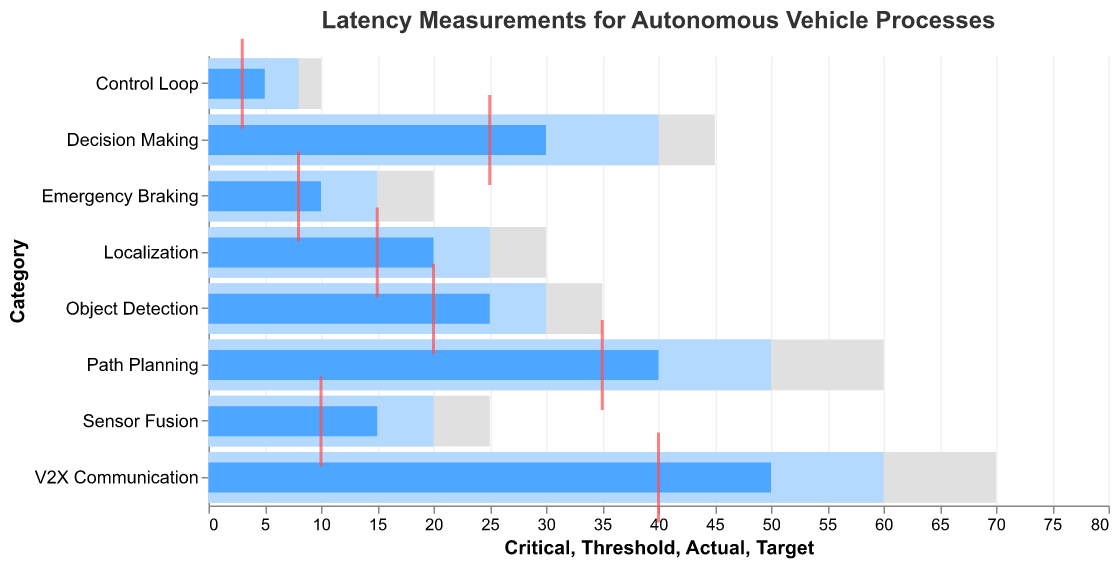What's the maximum latency measurement recorded in the figure? Observe all the Actual latency bars and identify the maximum value, which is 50 for V2X Communication.
Answer: 50 Which process has the smallest actual latency measurement? Find the smallest Actual latency value among the bars, which is 5 for the Control Loop.
Answer: Control Loop How many processes have an actual latency higher than their target latency? Compare Actual with Target for each process. They are higher for Sensor Fusion, Object Detection, Path Planning, Decision Making, V2X Communication, Localization, and Emergency Braking (7 processes).
Answer: 7 What's the difference between the actual latency and the threshold latency for Path Planning? Subtract the Threshold value (50) from the Actual latency value (40) for Path Planning.
Answer: -10 Which processes have an actual latency below the threshold but above the target latency? Check each process where Actual < Threshold and Actual > Target: Sensor Fusion, Object Detection, Decision Making, Localization, Emergency Braking, Control Loop.
Answer: Sensor Fusion, Object Detection, Decision Making, Localization, Emergency Braking, Control Loop Is the actual latency of any process exceeding the critical latency? Compare each process's Actual latency with Critical latency. None exceed the Critical latencies.
Answer: No What is the average target latency across all processes? Sum of Target latencies (10 + 20 + 35 + 25 + 3 + 40 + 15 + 8) = 156. The number of processes is 8, so the average is 156 / 8.
Answer: 19.5 Which process has the largest variance between its actual and target latency? Calculate the differences between Actual and Target for each process and find the largest difference, which is for V2X Communication (50 - 40 = 10).
Answer: V2X Communication 